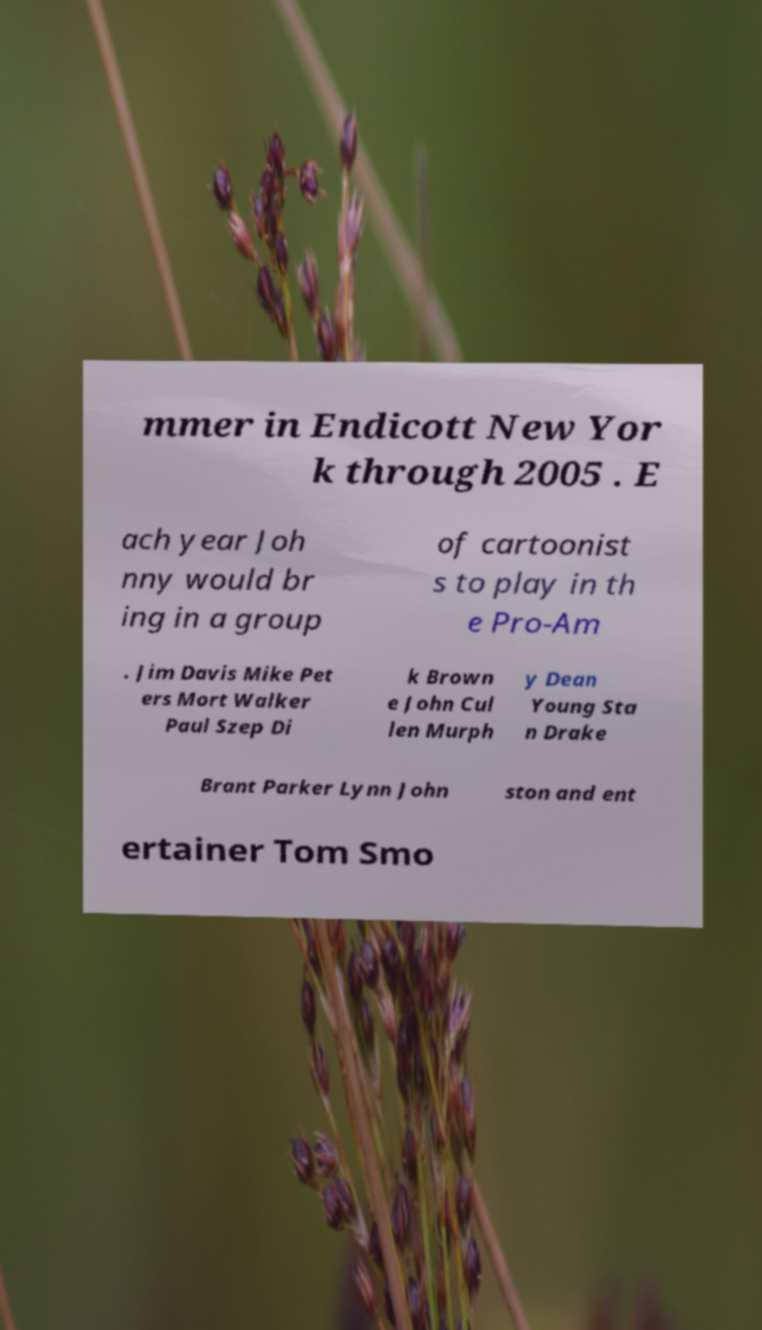Can you accurately transcribe the text from the provided image for me? mmer in Endicott New Yor k through 2005 . E ach year Joh nny would br ing in a group of cartoonist s to play in th e Pro-Am . Jim Davis Mike Pet ers Mort Walker Paul Szep Di k Brown e John Cul len Murph y Dean Young Sta n Drake Brant Parker Lynn John ston and ent ertainer Tom Smo 